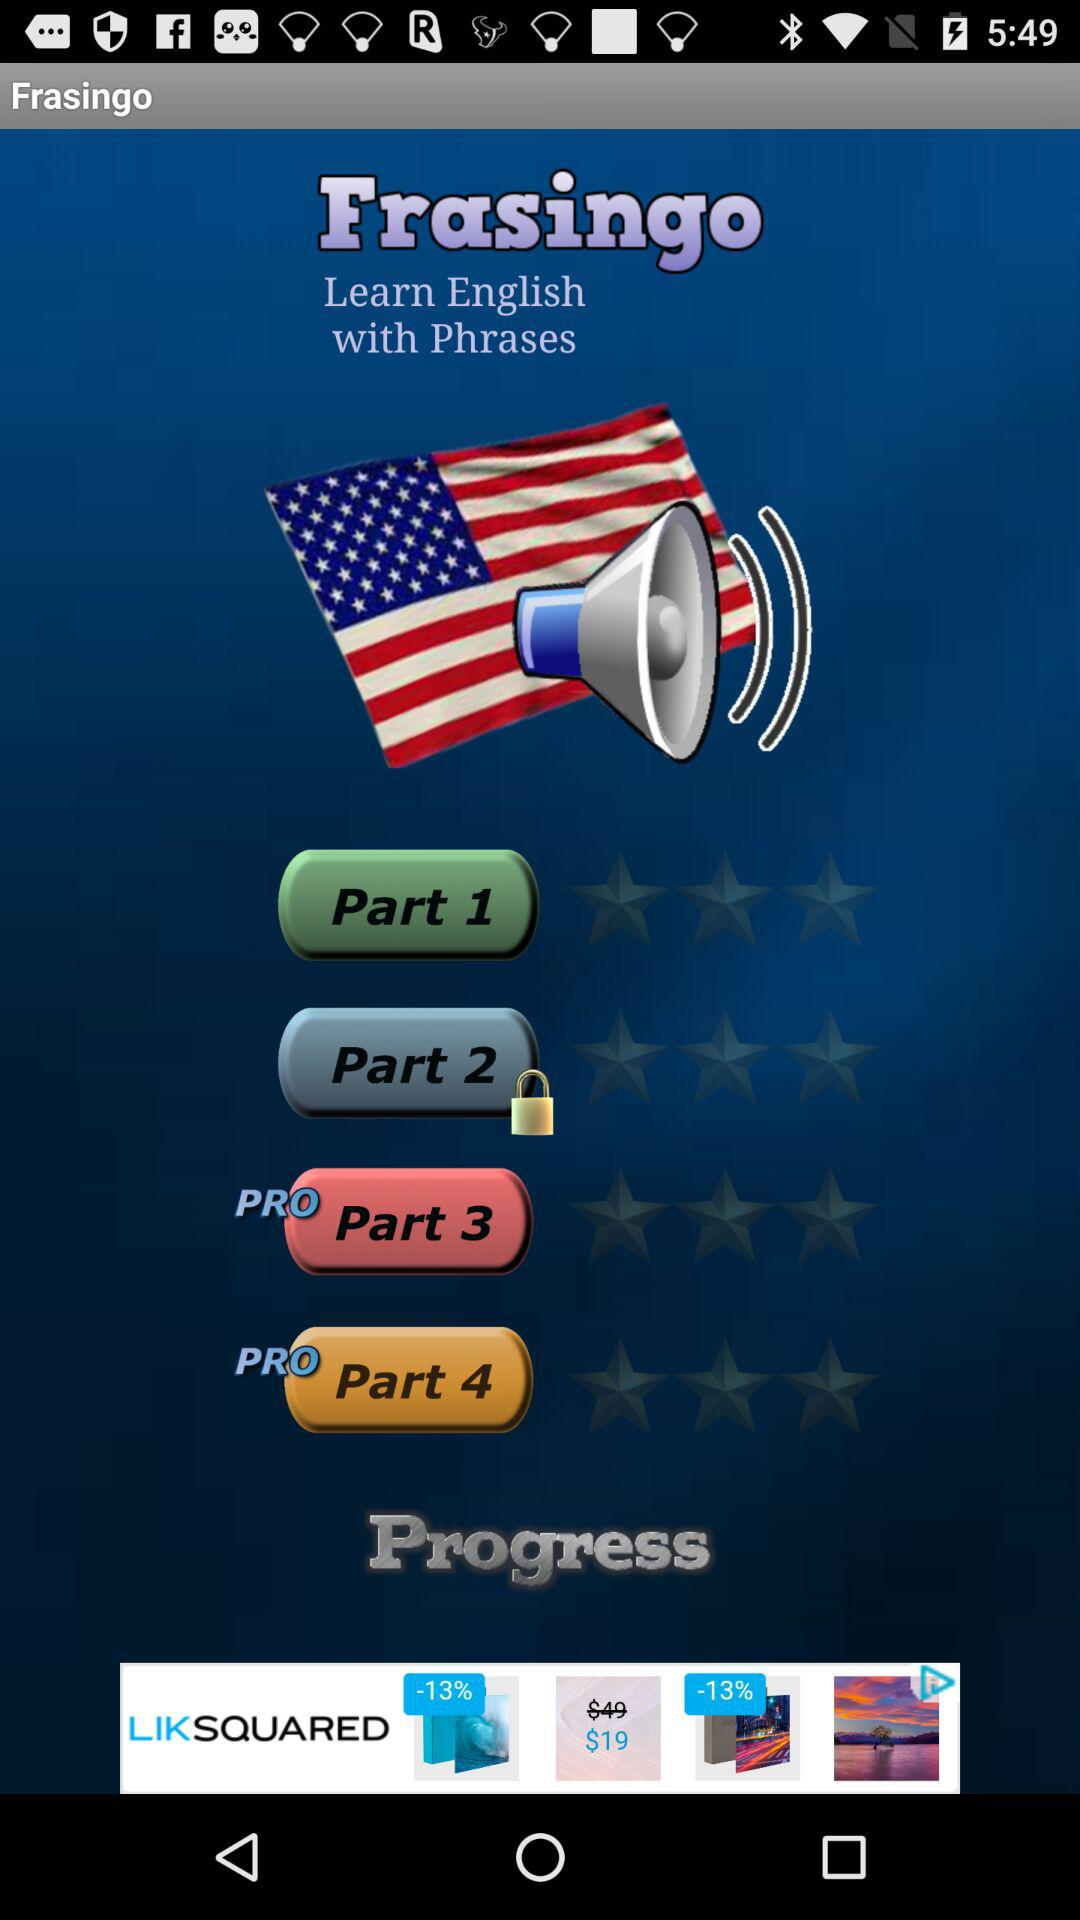How many questions are in "Part 2"?
When the provided information is insufficient, respond with <no answer>. <no answer> 